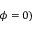Convert formula to latex. <formula><loc_0><loc_0><loc_500><loc_500>\phi = 0 )</formula> 